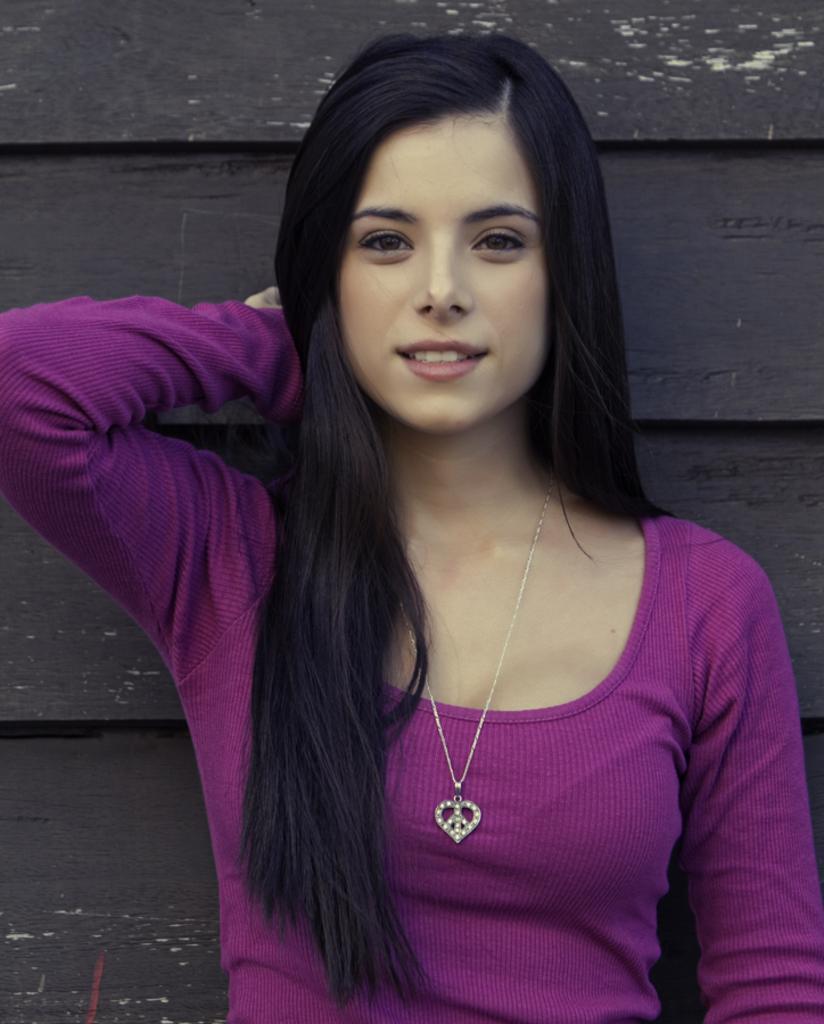How would you summarize this image in a sentence or two? The girl in the purple T-shirt is standing. She is smiling and she is posing for the photo. In the background, it is black in color. 